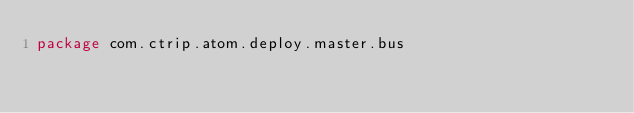<code> <loc_0><loc_0><loc_500><loc_500><_Scala_>package com.ctrip.atom.deploy.master.bus
</code> 